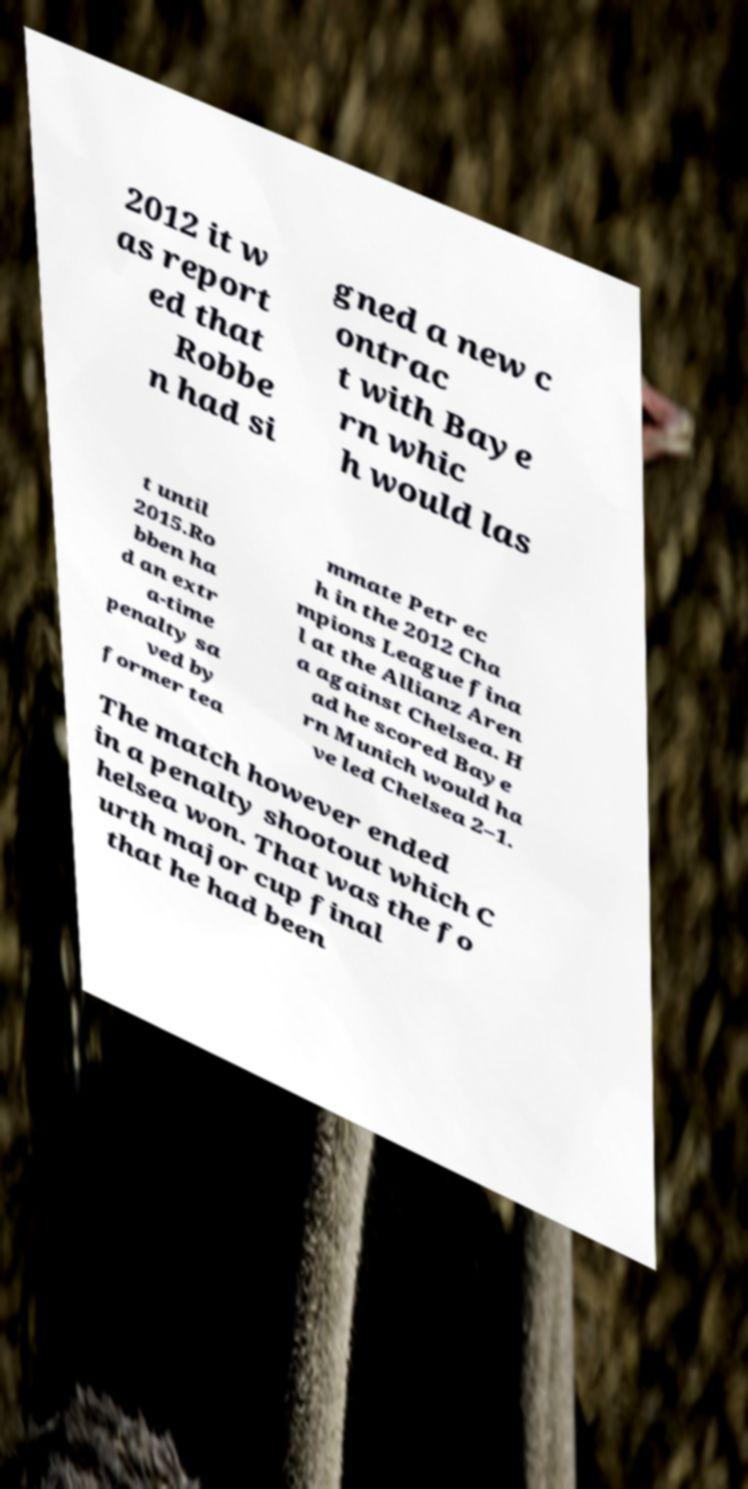Can you read and provide the text displayed in the image?This photo seems to have some interesting text. Can you extract and type it out for me? 2012 it w as report ed that Robbe n had si gned a new c ontrac t with Baye rn whic h would las t until 2015.Ro bben ha d an extr a-time penalty sa ved by former tea mmate Petr ec h in the 2012 Cha mpions League fina l at the Allianz Aren a against Chelsea. H ad he scored Baye rn Munich would ha ve led Chelsea 2–1. The match however ended in a penalty shootout which C helsea won. That was the fo urth major cup final that he had been 